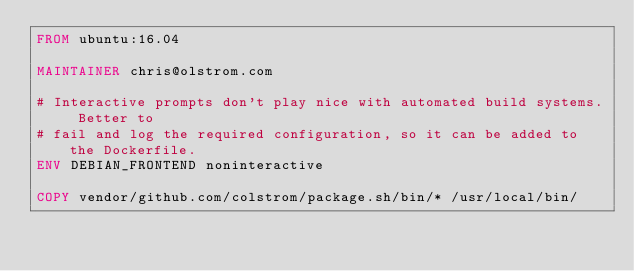Convert code to text. <code><loc_0><loc_0><loc_500><loc_500><_Dockerfile_>FROM ubuntu:16.04

MAINTAINER chris@olstrom.com

# Interactive prompts don't play nice with automated build systems. Better to
# fail and log the required configuration, so it can be added to the Dockerfile.
ENV DEBIAN_FRONTEND noninteractive

COPY vendor/github.com/colstrom/package.sh/bin/* /usr/local/bin/
</code> 